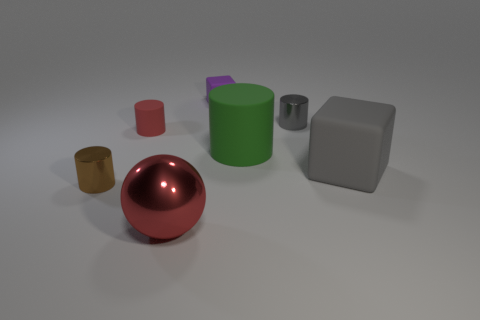What shape is the gray thing that is the same size as the red shiny object?
Your response must be concise. Cube. The big matte object that is behind the block in front of the matte object behind the small red thing is what color?
Offer a very short reply. Green. Is the gray metallic object the same shape as the small red thing?
Your answer should be compact. Yes. Are there the same number of large cylinders right of the gray rubber object and big gray metallic cubes?
Offer a very short reply. Yes. What number of other things are there of the same material as the gray cylinder
Your response must be concise. 2. Do the cube in front of the gray metal object and the matte cylinder that is to the right of the purple block have the same size?
Your answer should be very brief. Yes. What number of things are small brown metallic things that are in front of the large matte cube or tiny things that are behind the small gray metallic thing?
Your response must be concise. 2. Is there anything else that is the same shape as the tiny brown thing?
Provide a short and direct response. Yes. Does the tiny thing in front of the tiny red thing have the same color as the shiny object right of the small rubber cube?
Make the answer very short. No. What number of metallic things are gray things or small brown cylinders?
Keep it short and to the point. 2. 